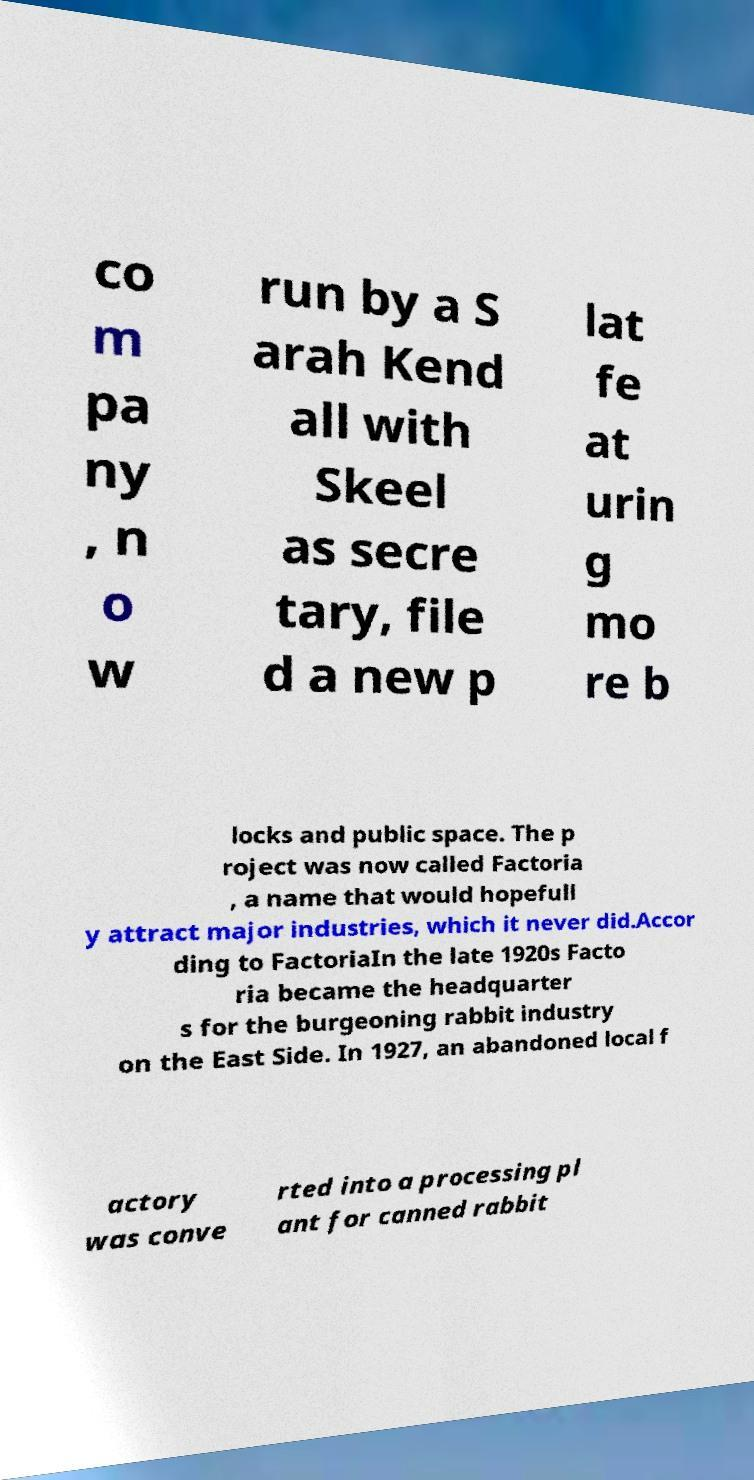For documentation purposes, I need the text within this image transcribed. Could you provide that? co m pa ny , n o w run by a S arah Kend all with Skeel as secre tary, file d a new p lat fe at urin g mo re b locks and public space. The p roject was now called Factoria , a name that would hopefull y attract major industries, which it never did.Accor ding to FactoriaIn the late 1920s Facto ria became the headquarter s for the burgeoning rabbit industry on the East Side. In 1927, an abandoned local f actory was conve rted into a processing pl ant for canned rabbit 